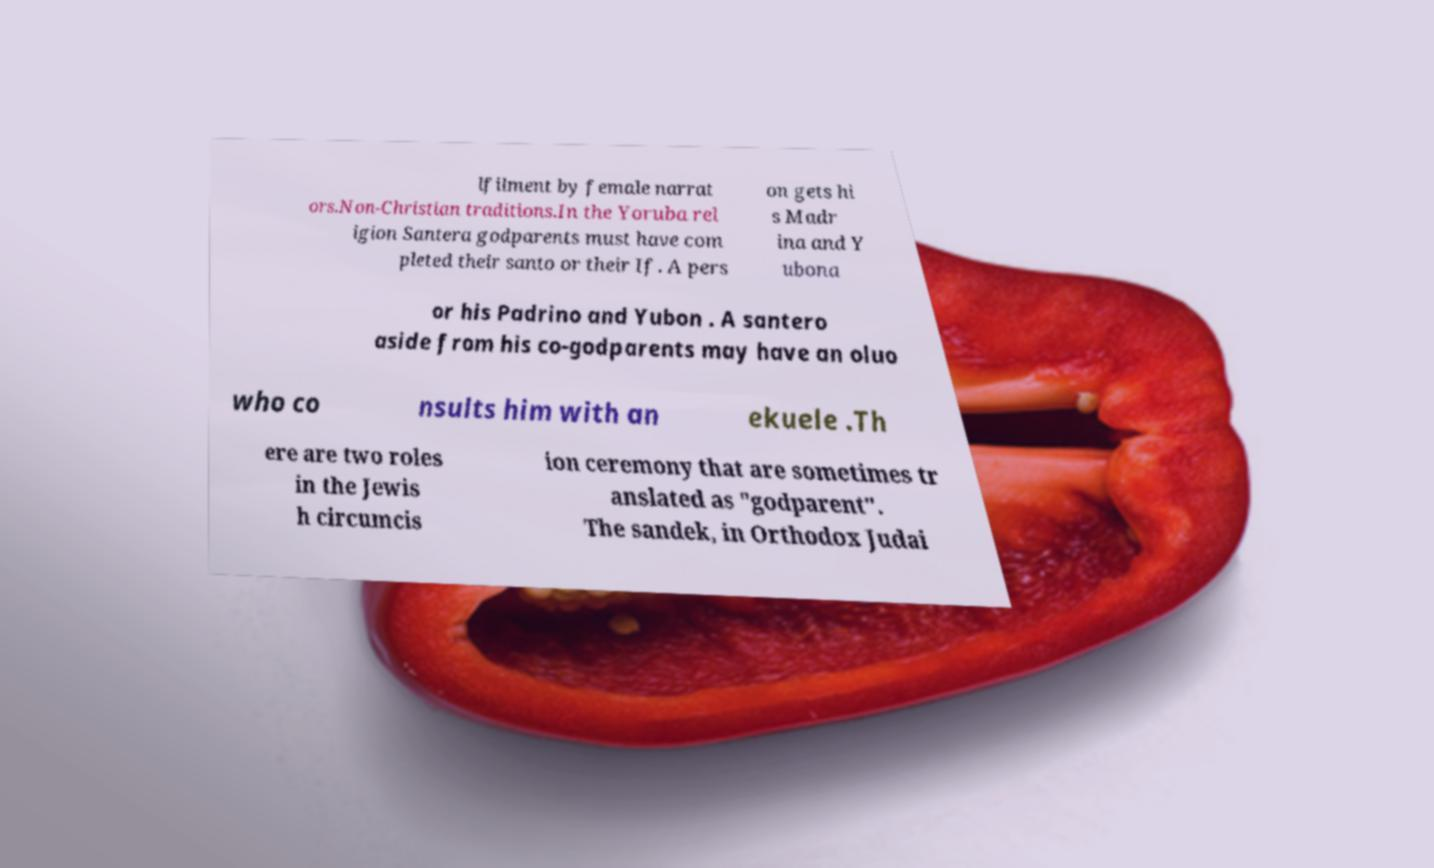Can you read and provide the text displayed in the image?This photo seems to have some interesting text. Can you extract and type it out for me? lfilment by female narrat ors.Non-Christian traditions.In the Yoruba rel igion Santera godparents must have com pleted their santo or their If. A pers on gets hi s Madr ina and Y ubona or his Padrino and Yubon . A santero aside from his co-godparents may have an oluo who co nsults him with an ekuele .Th ere are two roles in the Jewis h circumcis ion ceremony that are sometimes tr anslated as "godparent". The sandek, in Orthodox Judai 